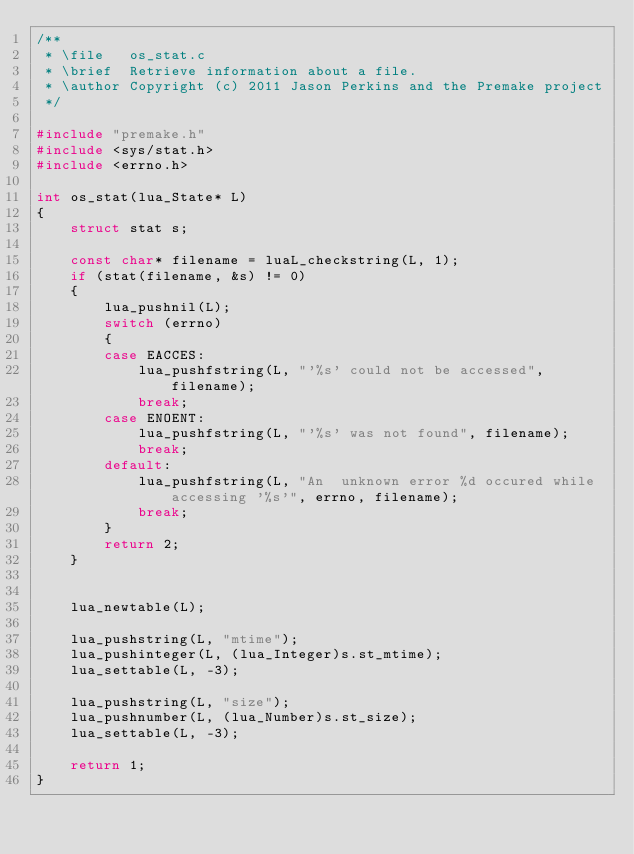<code> <loc_0><loc_0><loc_500><loc_500><_C_>/**
 * \file   os_stat.c
 * \brief  Retrieve information about a file.
 * \author Copyright (c) 2011 Jason Perkins and the Premake project
 */

#include "premake.h"
#include <sys/stat.h>
#include <errno.h>

int os_stat(lua_State* L)
{
	struct stat s;
	
	const char* filename = luaL_checkstring(L, 1);
    if (stat(filename, &s) != 0)
	{
		lua_pushnil(L);
		switch (errno)
		{
		case EACCES:
			lua_pushfstring(L, "'%s' could not be accessed", filename);
			break;
		case ENOENT:
			lua_pushfstring(L, "'%s' was not found", filename);
			break;
		default:	
			lua_pushfstring(L, "An  unknown error %d occured while accessing '%s'", errno, filename);
			break;
		}
		return 2;
	}
	
	
	lua_newtable(L);

	lua_pushstring(L, "mtime");
	lua_pushinteger(L, (lua_Integer)s.st_mtime);
	lua_settable(L, -3);

	lua_pushstring(L, "size");
	lua_pushnumber(L, (lua_Number)s.st_size);
	lua_settable(L, -3);

	return 1;
}
</code> 